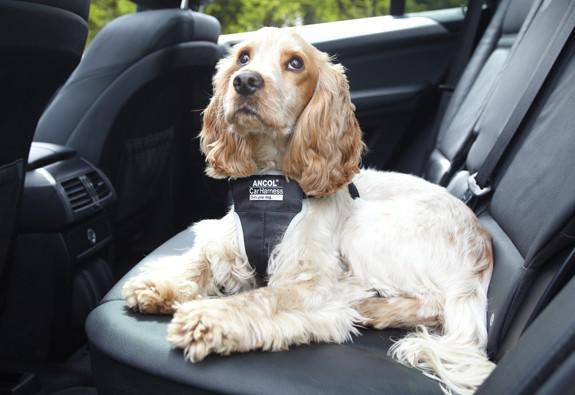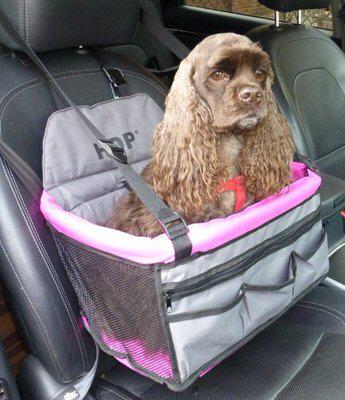The first image is the image on the left, the second image is the image on the right. For the images shown, is this caption "One dog is riding in a carrier." true? Answer yes or no. Yes. The first image is the image on the left, the second image is the image on the right. For the images displayed, is the sentence "Each image shows one spaniel riding in a car, and one image shows a spaniel sitting in a soft-sided box suspended over a seat by seat belts." factually correct? Answer yes or no. Yes. 